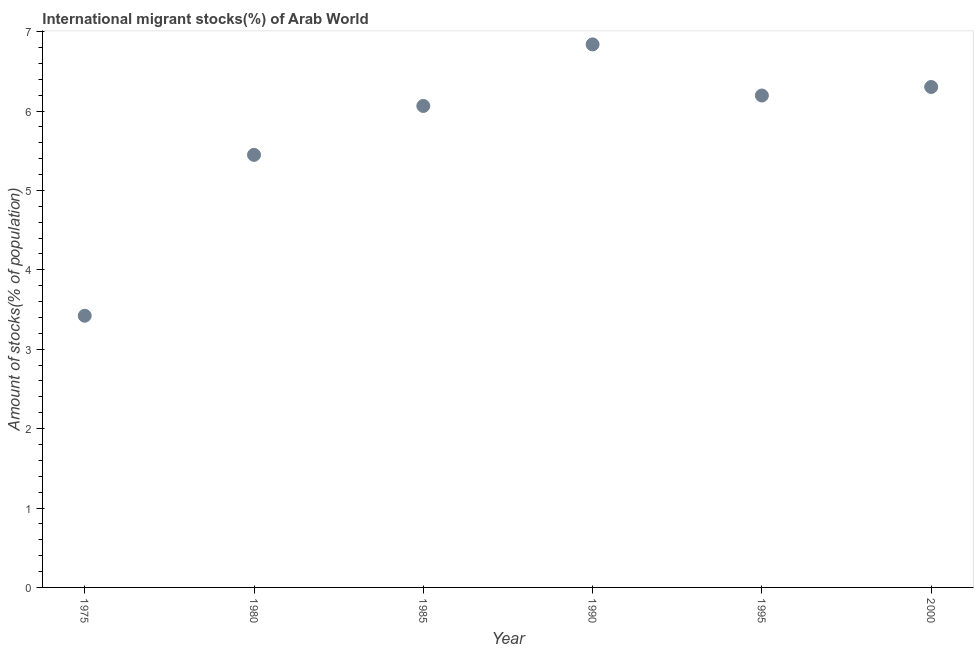What is the number of international migrant stocks in 1990?
Ensure brevity in your answer.  6.84. Across all years, what is the maximum number of international migrant stocks?
Give a very brief answer. 6.84. Across all years, what is the minimum number of international migrant stocks?
Offer a very short reply. 3.42. In which year was the number of international migrant stocks maximum?
Keep it short and to the point. 1990. In which year was the number of international migrant stocks minimum?
Make the answer very short. 1975. What is the sum of the number of international migrant stocks?
Make the answer very short. 34.27. What is the difference between the number of international migrant stocks in 1995 and 2000?
Your response must be concise. -0.11. What is the average number of international migrant stocks per year?
Offer a terse response. 5.71. What is the median number of international migrant stocks?
Provide a short and direct response. 6.13. In how many years, is the number of international migrant stocks greater than 5 %?
Offer a terse response. 5. What is the ratio of the number of international migrant stocks in 1975 to that in 2000?
Offer a very short reply. 0.54. Is the number of international migrant stocks in 1980 less than that in 1995?
Your answer should be compact. Yes. Is the difference between the number of international migrant stocks in 1995 and 2000 greater than the difference between any two years?
Offer a terse response. No. What is the difference between the highest and the second highest number of international migrant stocks?
Your answer should be very brief. 0.54. Is the sum of the number of international migrant stocks in 1975 and 2000 greater than the maximum number of international migrant stocks across all years?
Give a very brief answer. Yes. What is the difference between the highest and the lowest number of international migrant stocks?
Your response must be concise. 3.42. How many dotlines are there?
Offer a very short reply. 1. What is the difference between two consecutive major ticks on the Y-axis?
Give a very brief answer. 1. Does the graph contain any zero values?
Your response must be concise. No. What is the title of the graph?
Keep it short and to the point. International migrant stocks(%) of Arab World. What is the label or title of the Y-axis?
Provide a succinct answer. Amount of stocks(% of population). What is the Amount of stocks(% of population) in 1975?
Make the answer very short. 3.42. What is the Amount of stocks(% of population) in 1980?
Provide a succinct answer. 5.45. What is the Amount of stocks(% of population) in 1985?
Make the answer very short. 6.06. What is the Amount of stocks(% of population) in 1990?
Make the answer very short. 6.84. What is the Amount of stocks(% of population) in 1995?
Keep it short and to the point. 6.2. What is the Amount of stocks(% of population) in 2000?
Give a very brief answer. 6.3. What is the difference between the Amount of stocks(% of population) in 1975 and 1980?
Give a very brief answer. -2.03. What is the difference between the Amount of stocks(% of population) in 1975 and 1985?
Your response must be concise. -2.64. What is the difference between the Amount of stocks(% of population) in 1975 and 1990?
Ensure brevity in your answer.  -3.42. What is the difference between the Amount of stocks(% of population) in 1975 and 1995?
Your answer should be compact. -2.77. What is the difference between the Amount of stocks(% of population) in 1975 and 2000?
Your answer should be compact. -2.88. What is the difference between the Amount of stocks(% of population) in 1980 and 1985?
Keep it short and to the point. -0.62. What is the difference between the Amount of stocks(% of population) in 1980 and 1990?
Your response must be concise. -1.39. What is the difference between the Amount of stocks(% of population) in 1980 and 1995?
Your answer should be very brief. -0.75. What is the difference between the Amount of stocks(% of population) in 1980 and 2000?
Your response must be concise. -0.85. What is the difference between the Amount of stocks(% of population) in 1985 and 1990?
Ensure brevity in your answer.  -0.78. What is the difference between the Amount of stocks(% of population) in 1985 and 1995?
Offer a very short reply. -0.13. What is the difference between the Amount of stocks(% of population) in 1985 and 2000?
Give a very brief answer. -0.24. What is the difference between the Amount of stocks(% of population) in 1990 and 1995?
Ensure brevity in your answer.  0.64. What is the difference between the Amount of stocks(% of population) in 1990 and 2000?
Keep it short and to the point. 0.54. What is the difference between the Amount of stocks(% of population) in 1995 and 2000?
Your answer should be very brief. -0.11. What is the ratio of the Amount of stocks(% of population) in 1975 to that in 1980?
Make the answer very short. 0.63. What is the ratio of the Amount of stocks(% of population) in 1975 to that in 1985?
Offer a very short reply. 0.56. What is the ratio of the Amount of stocks(% of population) in 1975 to that in 1990?
Keep it short and to the point. 0.5. What is the ratio of the Amount of stocks(% of population) in 1975 to that in 1995?
Keep it short and to the point. 0.55. What is the ratio of the Amount of stocks(% of population) in 1975 to that in 2000?
Make the answer very short. 0.54. What is the ratio of the Amount of stocks(% of population) in 1980 to that in 1985?
Your response must be concise. 0.9. What is the ratio of the Amount of stocks(% of population) in 1980 to that in 1990?
Your response must be concise. 0.8. What is the ratio of the Amount of stocks(% of population) in 1980 to that in 1995?
Give a very brief answer. 0.88. What is the ratio of the Amount of stocks(% of population) in 1980 to that in 2000?
Offer a very short reply. 0.86. What is the ratio of the Amount of stocks(% of population) in 1985 to that in 1990?
Make the answer very short. 0.89. What is the ratio of the Amount of stocks(% of population) in 1985 to that in 1995?
Provide a short and direct response. 0.98. What is the ratio of the Amount of stocks(% of population) in 1985 to that in 2000?
Offer a very short reply. 0.96. What is the ratio of the Amount of stocks(% of population) in 1990 to that in 1995?
Offer a very short reply. 1.1. What is the ratio of the Amount of stocks(% of population) in 1990 to that in 2000?
Give a very brief answer. 1.08. What is the ratio of the Amount of stocks(% of population) in 1995 to that in 2000?
Provide a short and direct response. 0.98. 